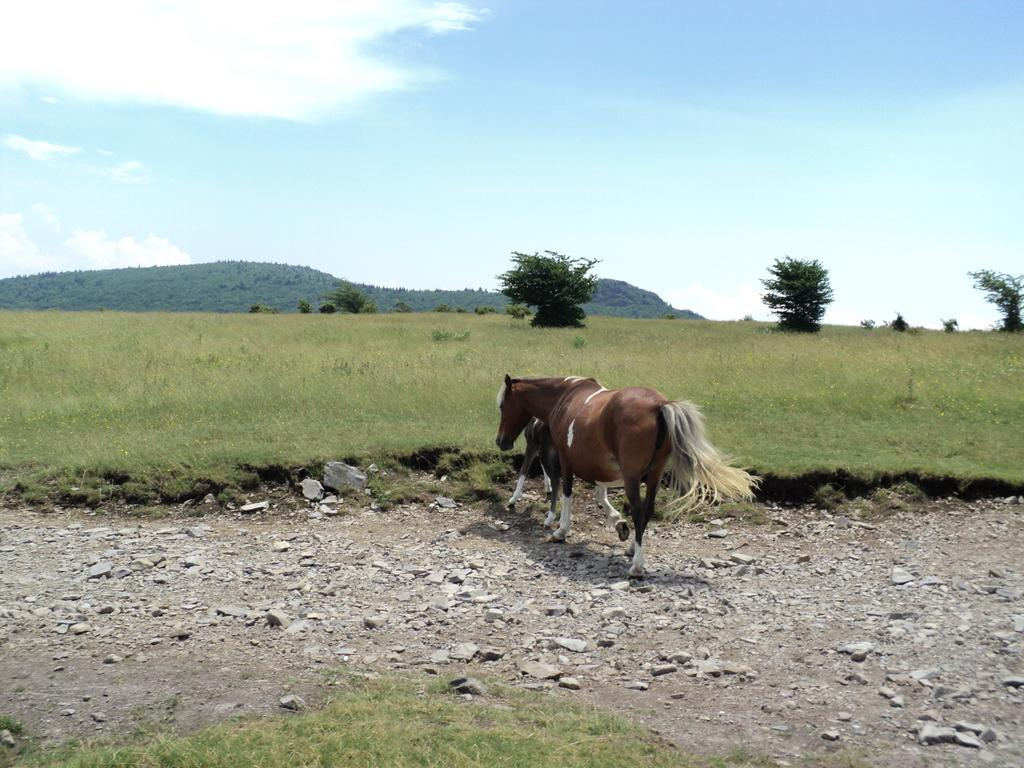What type of animal can be seen in the image? There is a horse in the image. Can you describe the path in the image? There is an animal on the path in the image. What is the ground made of in the image? There are stones and grass on the ground in the image. What can be seen in the background of the image? There are trees visible in the background of the image. What type of skirt is the horse wearing in the image? There is no skirt present in the image, as horses do not wear clothing. 